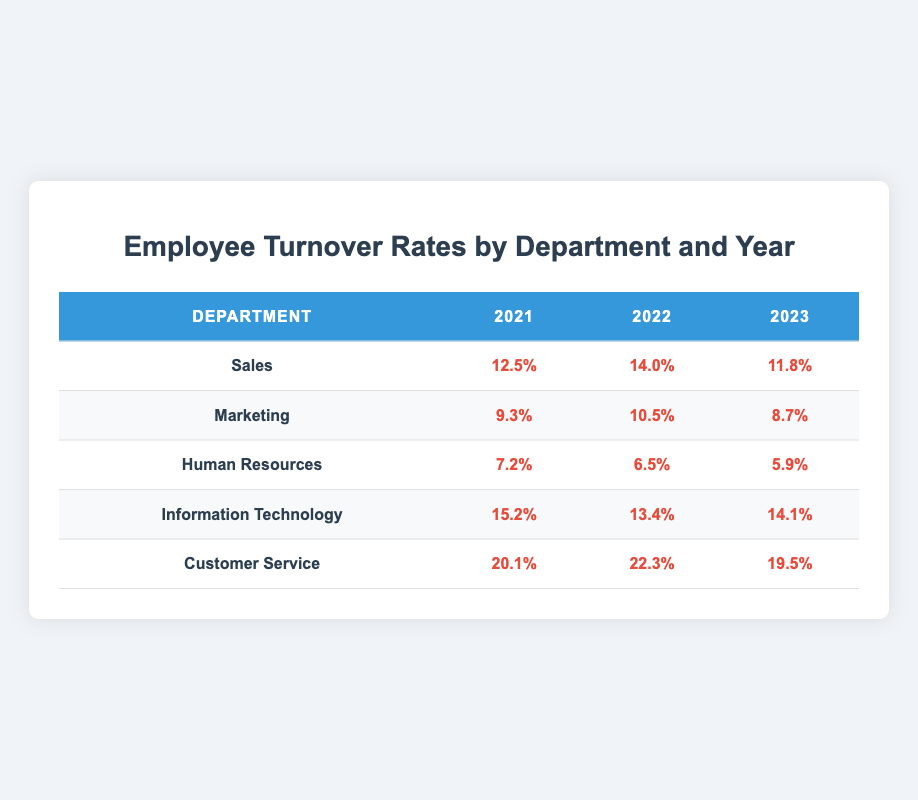What was the turnover rate for the Sales department in 2022? According to the table, the turnover rate for the Sales department in 2022 is the value directly provided in that row and column, which is 14.0%.
Answer: 14.0% Which department had the highest turnover rate in 2021? By checking the turnover rates for all departments in 2021, Customer Service shows the highest turnover rate at 20.1%.
Answer: Customer Service What is the average turnover rate for the Marketing department over the three years? To find the average, we add the turnover rates for Marketing across the three years: (9.3 + 10.5 + 8.7) = 28.5%. Then, we divide by 3 to get the average: 28.5 / 3 = 9.5%.
Answer: 9.5% Did the turnover rate for Human Resources decrease from 2021 to 2023? Analyzing the turnover rates from Human Resources: in 2021 it was 7.2%, in 2022 it was 6.5%, and in 2023 it was 5.9%. Since all values are decreasing over these years, the answer is yes.
Answer: Yes What was the change in turnover rate for Customer Service between 2022 and 2023? To find the change, we subtract the turnover rate in 2023 from the rate in 2022: 22.3% - 19.5% = 2.8%. Therefore, there was a decrease of 2.8%.
Answer: 2.8% What is the turnover rate difference between the highest and lowest department in 2023? In 2023, the highest turnover rate is for Customer Service at 19.5%, while the lowest is for Human Resources at 5.9%. The difference is 19.5% - 5.9% = 13.6%.
Answer: 13.6% In which year did Information Technology show the lowest turnover rate? Looking across the three years for Information Technology, the turnover rates are 15.2%, 13.4%, and 14.1%. The lowest is in 2022 at 13.4%.
Answer: 2022 Has the turnover rate for the Sales department been consistently above or below 12% from 2021 to 2023? The turnover rates for Sales are 12.5% in 2021, 14.0% in 2022, and 11.8% in 2023. Since 2023 dips below 12%, the answer is no; it was not consistent.
Answer: No 